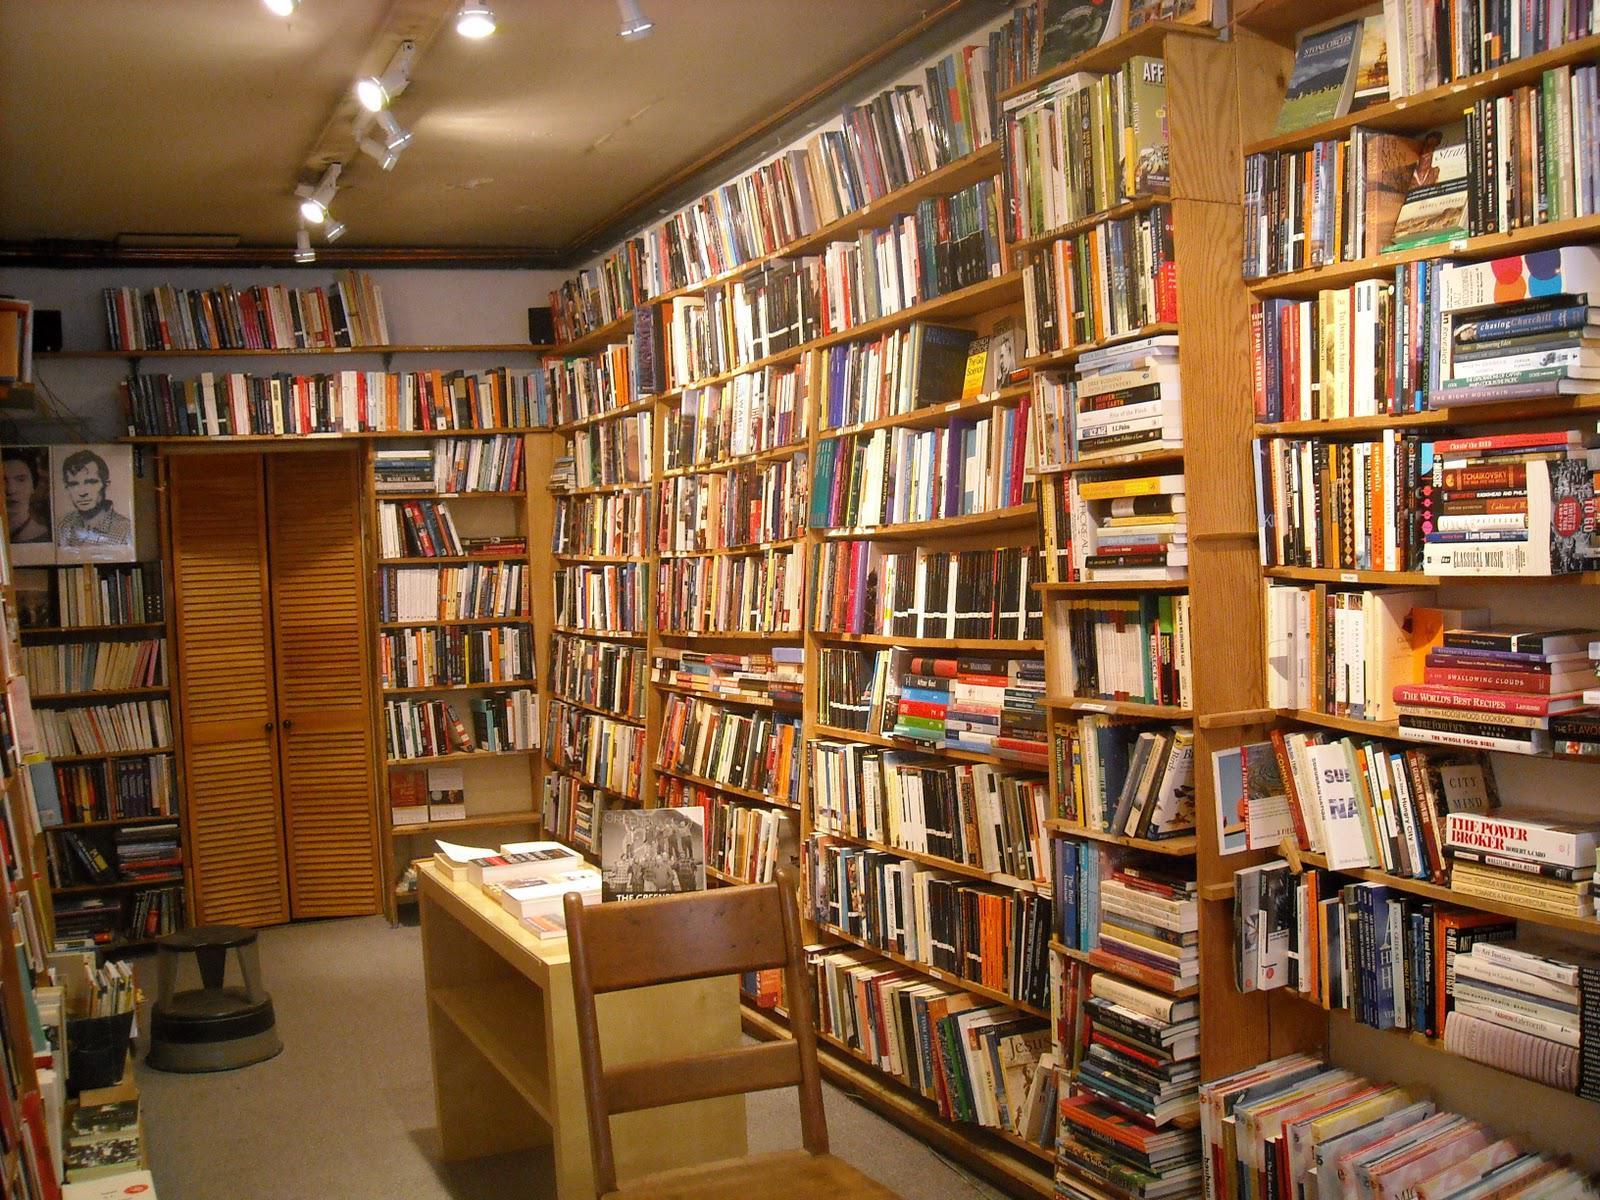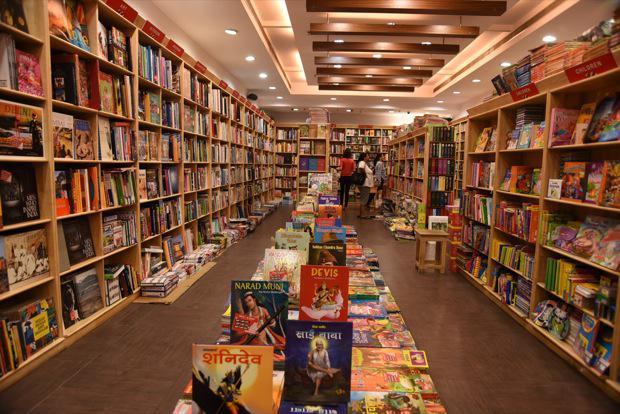The first image is the image on the left, the second image is the image on the right. For the images displayed, is the sentence "A back-turned person wearing something pinkish stands in the aisle at the very center of the bookstore, with tall shelves surrounding them." factually correct? Answer yes or no. No. The first image is the image on the left, the second image is the image on the right. Examine the images to the left and right. Is the description "Someone dressed all in black is in the center aisle of a bookstore." accurate? Answer yes or no. No. The first image is the image on the left, the second image is the image on the right. Given the left and right images, does the statement "there are at least three people in the image on the right" hold true? Answer yes or no. Yes. 